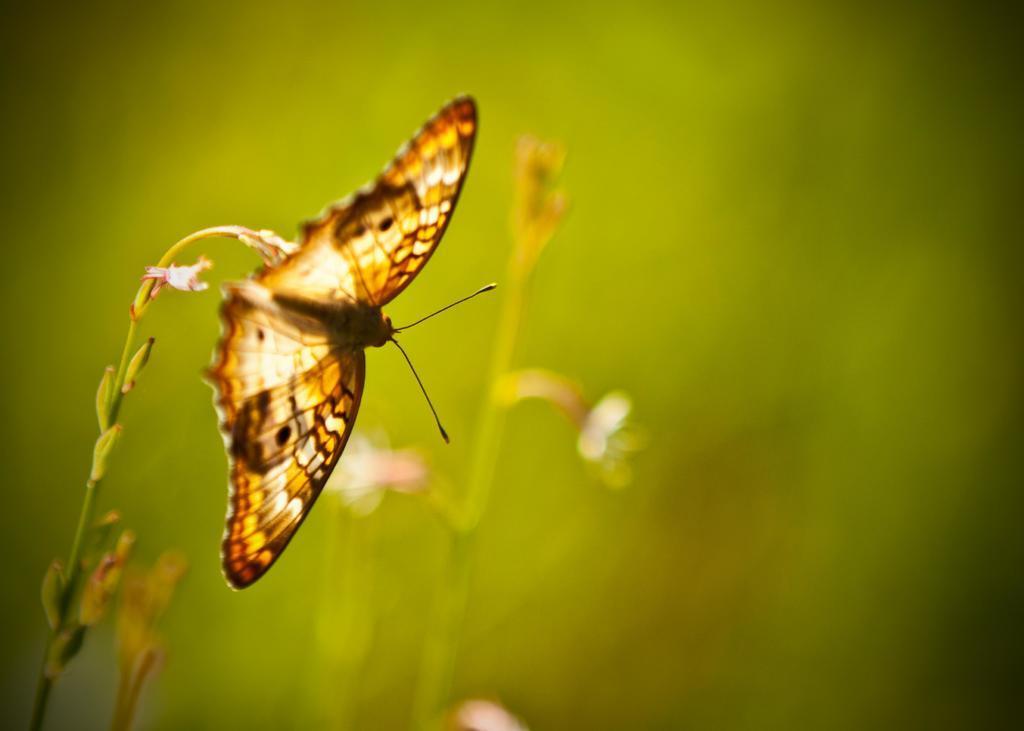How would you summarize this image in a sentence or two? In this image we can see a butterfly, plants, and flowers. There is a green color background. 